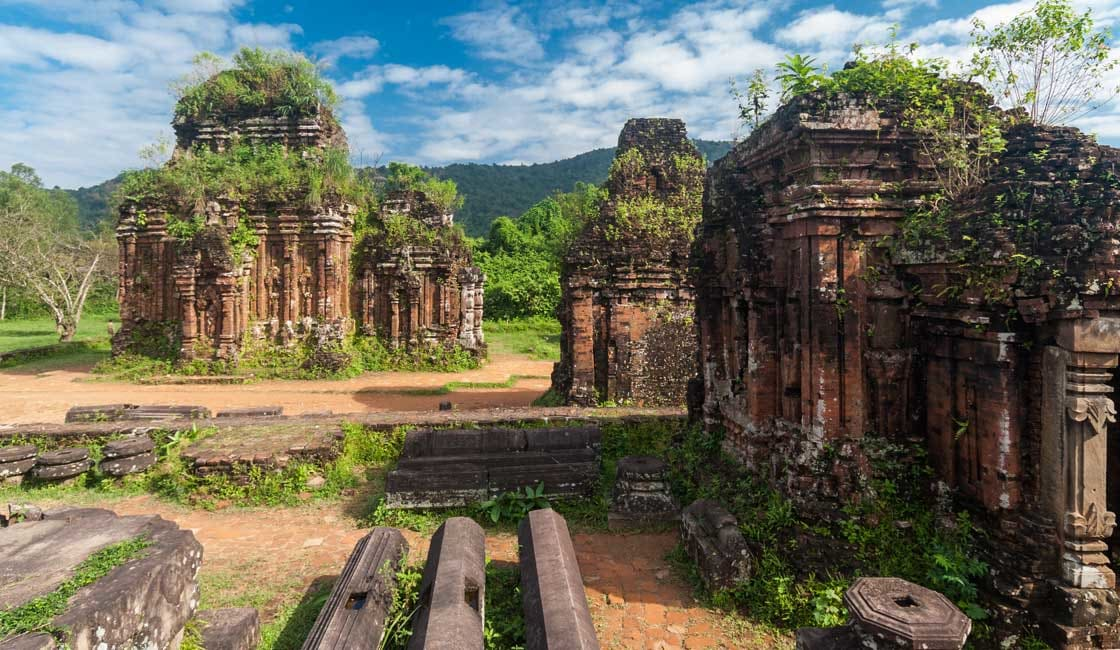What can you tell me about the history of these ruins? The My Son Sanctuary is a significant archaeological site that was the religious and political capital of the Champa Kingdom. The temples here were constructed over ten centuries and are a testament to the cultural influence of Hinduism in Southeast Asia. The site demonstrates the Champa Kingdom's dedication to Hindu gods, especially Shiva, and features many statues and reliefs depicting Hindu mythology. The site was largely forgotten until its rediscovery in the late 19th century by French scholars, and despite suffering damage during various conflicts, My Son remains a powerful symbol of a once-great civilization. 